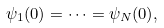Convert formula to latex. <formula><loc_0><loc_0><loc_500><loc_500>\psi _ { 1 } ( 0 ) = \dots = \psi _ { N } ( 0 ) ,</formula> 